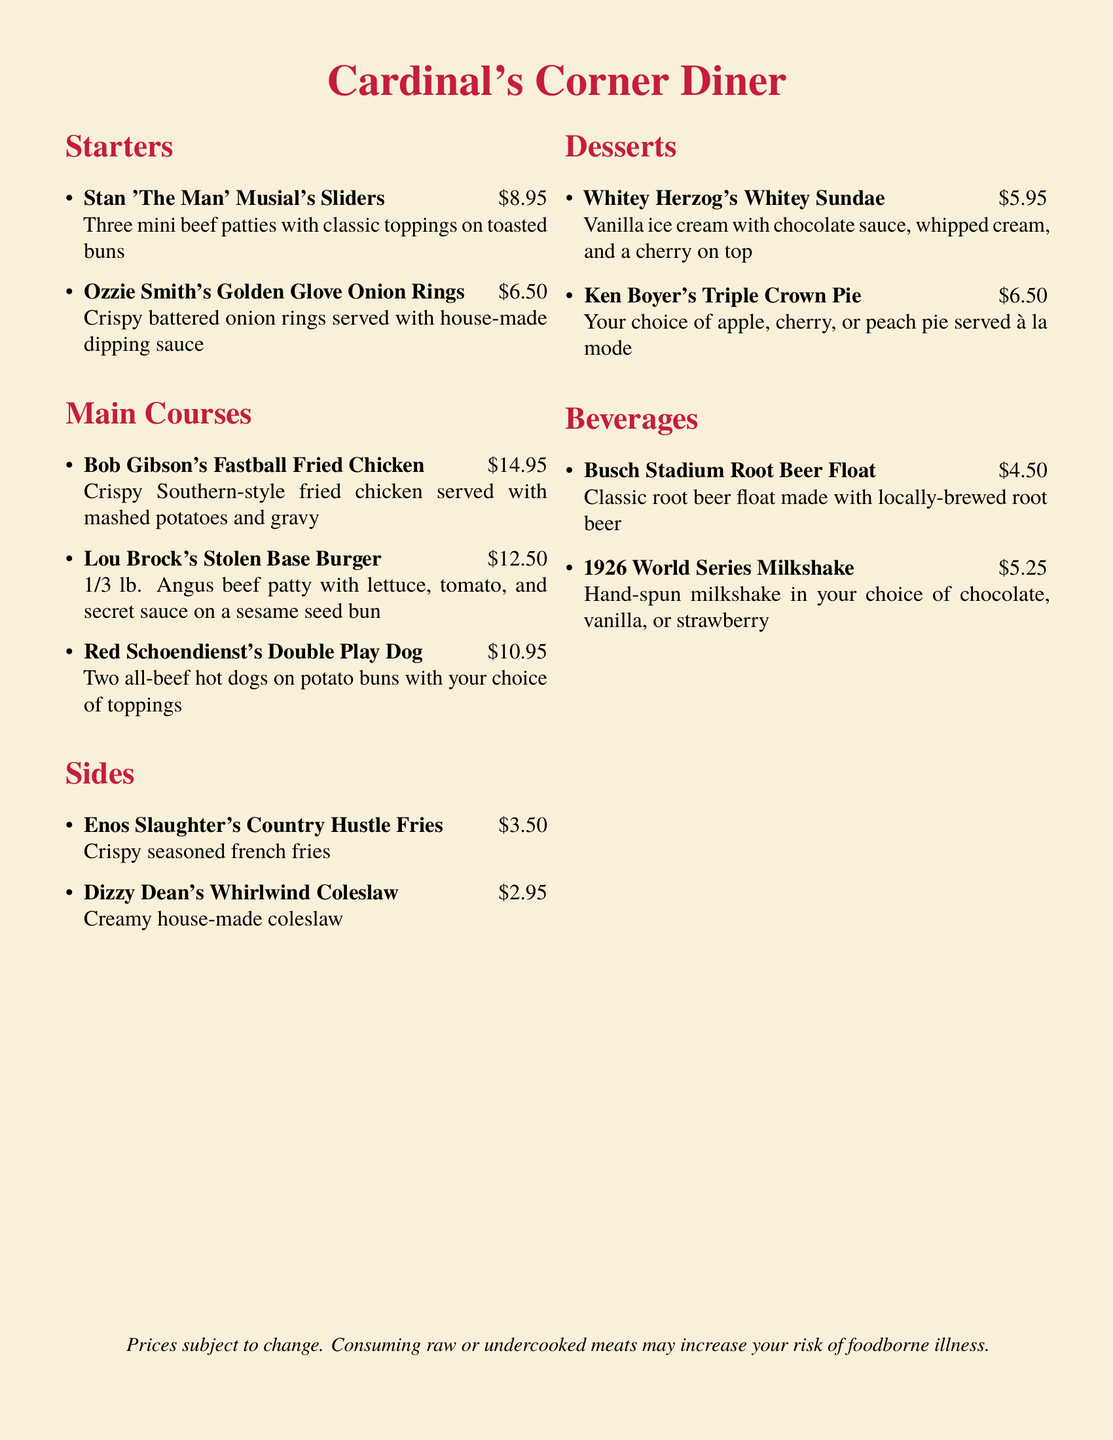What is the price of Stan 'The Man' Musial's Sliders? The price for Stan 'The Man' Musial's Sliders is stated in the menu, which is $8.95.
Answer: $8.95 How many mini patties are in the sliders? The menu specifies that there are three mini beef patties in Stan 'The Man' Musial's Sliders.
Answer: Three What is the name of the dessert that has a cherry on top? The menu mentions that Whitey Herzog's Whitey Sundae includes a cherry on top, as listed in the desserts section.
Answer: Whitey Herzog's Whitey Sundae Which side dish is creamy? The menu describes Dizzy Dean's Whirlwind Coleslaw as creamy, indicating its texture.
Answer: Whirlwind Coleslaw What main course is associated with Bob Gibson? The menu lists Bob Gibson's Fastball Fried Chicken as the main course named after him.
Answer: Fastball Fried Chicken How much does the 1926 World Series Milkshake cost? The menu states the price for the 1926 World Series Milkshake, which is $5.25.
Answer: $5.25 How many all-beef hot dogs are included in Red Schoendienst's Double Play Dog? The menu indicates that there are two all-beef hot dogs in Red Schoendienst's Double Play Dog.
Answer: Two What type of beverage is made with locally-brewed root beer? The menu specifies that the Busch Stadium Root Beer Float is made with locally-brewed root beer.
Answer: Root Beer Float Which item features a steak as its main ingredient? The menu does not feature any item with steak; hence there is no related item.
Answer: None 